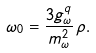<formula> <loc_0><loc_0><loc_500><loc_500>\omega _ { 0 } = \frac { 3 g ^ { q } _ { \omega } } { m _ { \omega } ^ { 2 } } \, \rho .</formula> 